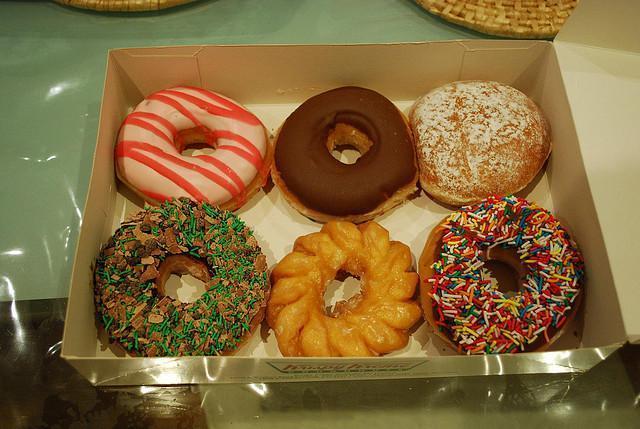How many types of doughnuts are there?
Give a very brief answer. 6. How many doughnuts have sprinkles?
Give a very brief answer. 2. How many consumable items are pictured?
Give a very brief answer. 6. How many donuts are there?
Give a very brief answer. 6. How many people are holding wine glasses?
Give a very brief answer. 0. 